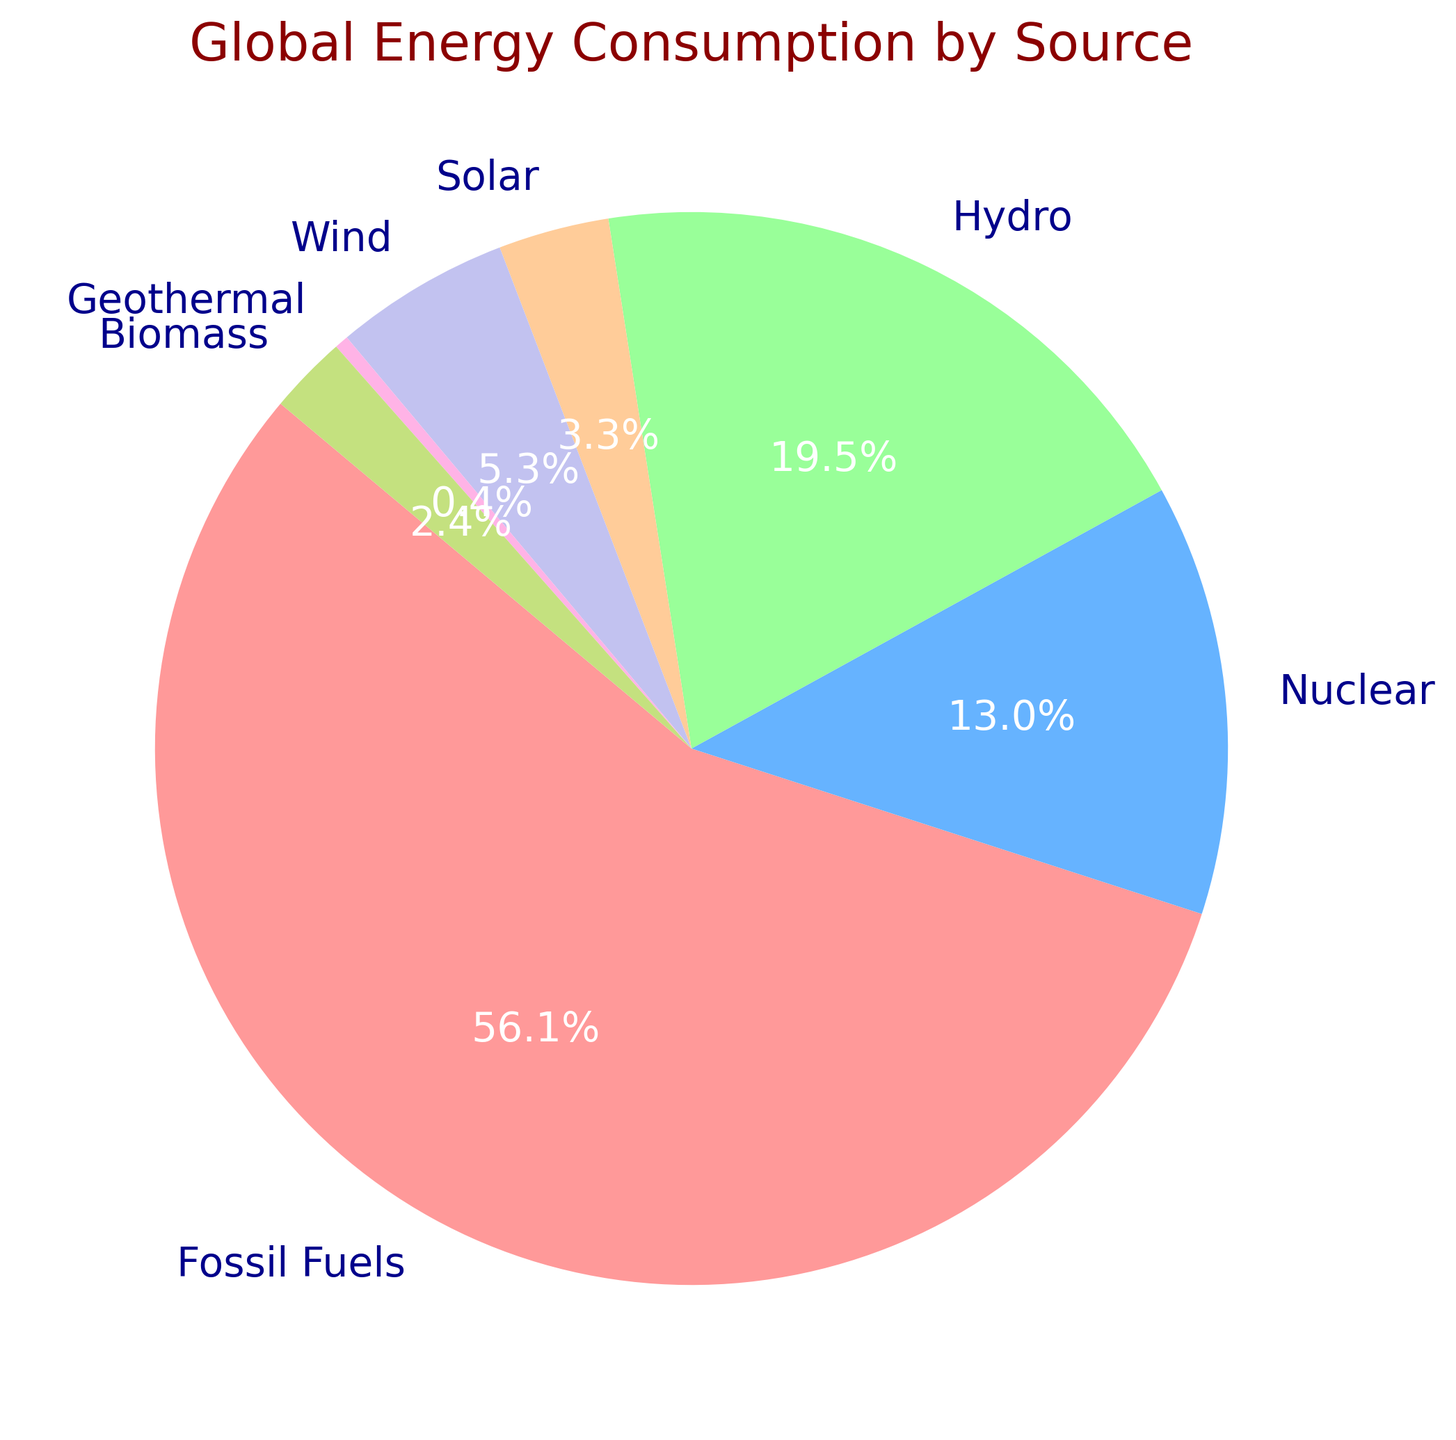Which energy source contributes the most to global energy consumption? The largest section of the pie chart corresponds to Fossil Fuels, indicating it has the highest consumption.
Answer: Fossil Fuels What percentage of global energy consumption is contributed by renewable sources? Renewable sources include Hydro, Solar, Wind, Geothermal, and Biomass. Summing their percentages: Hydro (23.3%) + Solar (4.0%) + Wind (6.3%) + Geothermal (0.5%) + Biomass (2.8%) = 36.9%
Answer: 36.9% How does the consumption of Nuclear energy compare to that of Hydro energy? By looking at the pie chart, we see that Hydro has a larger section than Nuclear. Hydro is 23.3% and Nuclear is 15.6%.
Answer: Hydro is greater If the energy consumption from Solar and Biomass were combined, what would be their total percentage? Solar (4.0%) + Biomass (2.8%) = 6.8%
Answer: 6.8% Which color represents Wind energy in the pie chart? By referring to the legend of the pie chart, Wind is represented with the light purple section.
Answer: Light purple Arrange the energy sources in decreasing order of consumption percentages. From the pie chart, the order is: Fossil Fuels (67.4%), Hydro (23.3%), Nuclear (15.6%), Wind (6.3%), Solar (4.0%), Biomass (2.8%), Geothermal (0.5%).
Answer: Fossil Fuels, Hydro, Nuclear, Wind, Solar, Biomass, Geothermal Is the combined consumption of Wind and Solar energy more than that of Nuclear energy? Wind (6.3%) + Solar (4.0%) = 10.3% which is less than Nuclear (15.6%).
Answer: No What is the smallest energy source in terms of global consumption? From the pie chart, the smallest section is Geothermal with 0.5%.
Answer: Geothermal 